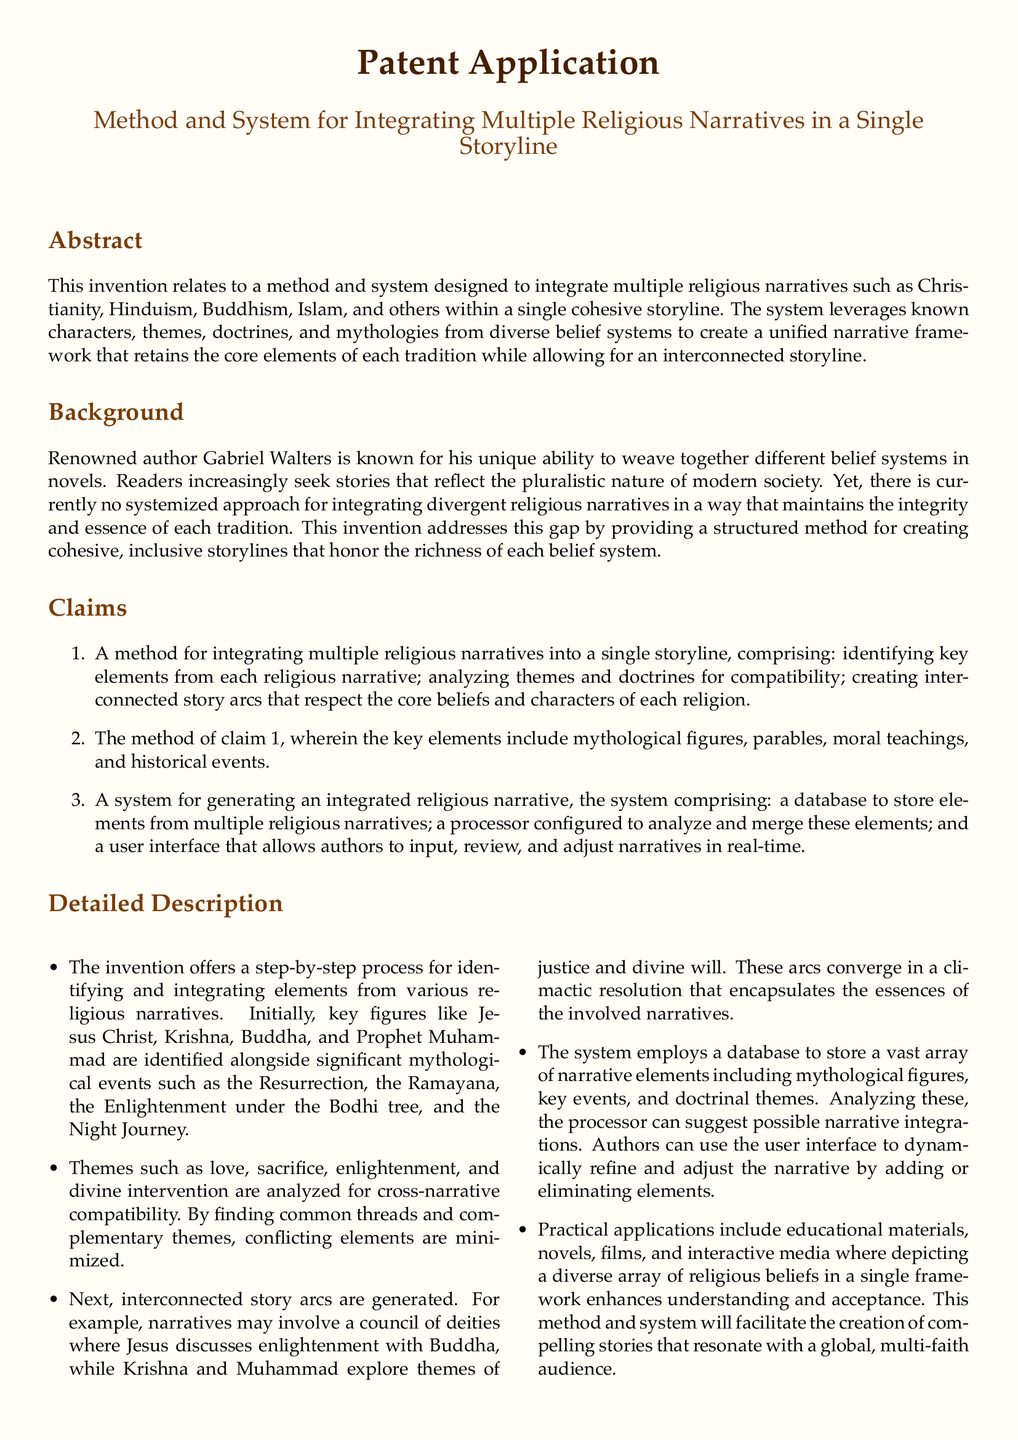What is the title of the patent application? The title reflects the main subject of the invention, which is to integrate multiple religious narratives.
Answer: Method and System for Integrating Multiple Religious Narratives in a Single Storyline Who is the renowned author mentioned in the document? The document references a specific individual recognized for this unique talent.
Answer: Gabriel Walters What are key components of the method described in claim 1? The claim outlines the necessary steps for integrating narratives, including identification and analysis.
Answer: Identifying key elements, analyzing themes and doctrines, creating interconnected story arcs Which religious figures are specifically mentioned in the detailed description? The description lists significant characters that are key to various religious traditions.
Answer: Jesus Christ, Krishna, Buddha, Prophet Muhammad What types of narrative elements does the system's database store? The document specifies what kinds of elements the database contains for analysis.
Answer: Mythological figures, key events, doctrinal themes What is a practical application mentioned for this method and system? The document gives various contexts where this integration method can be utilized.
Answer: Novels, films, interactive media How does the system assist authors? The user interface provides a specific functionality that allows creators to manage their narrative.
Answer: Input, review, and adjust narratives in real-time What themes are analyzed for cross-narrative compatibility? The document identifies specific concepts that are examined to create coherence among narratives.
Answer: Love, sacrifice, enlightenment, divine intervention 